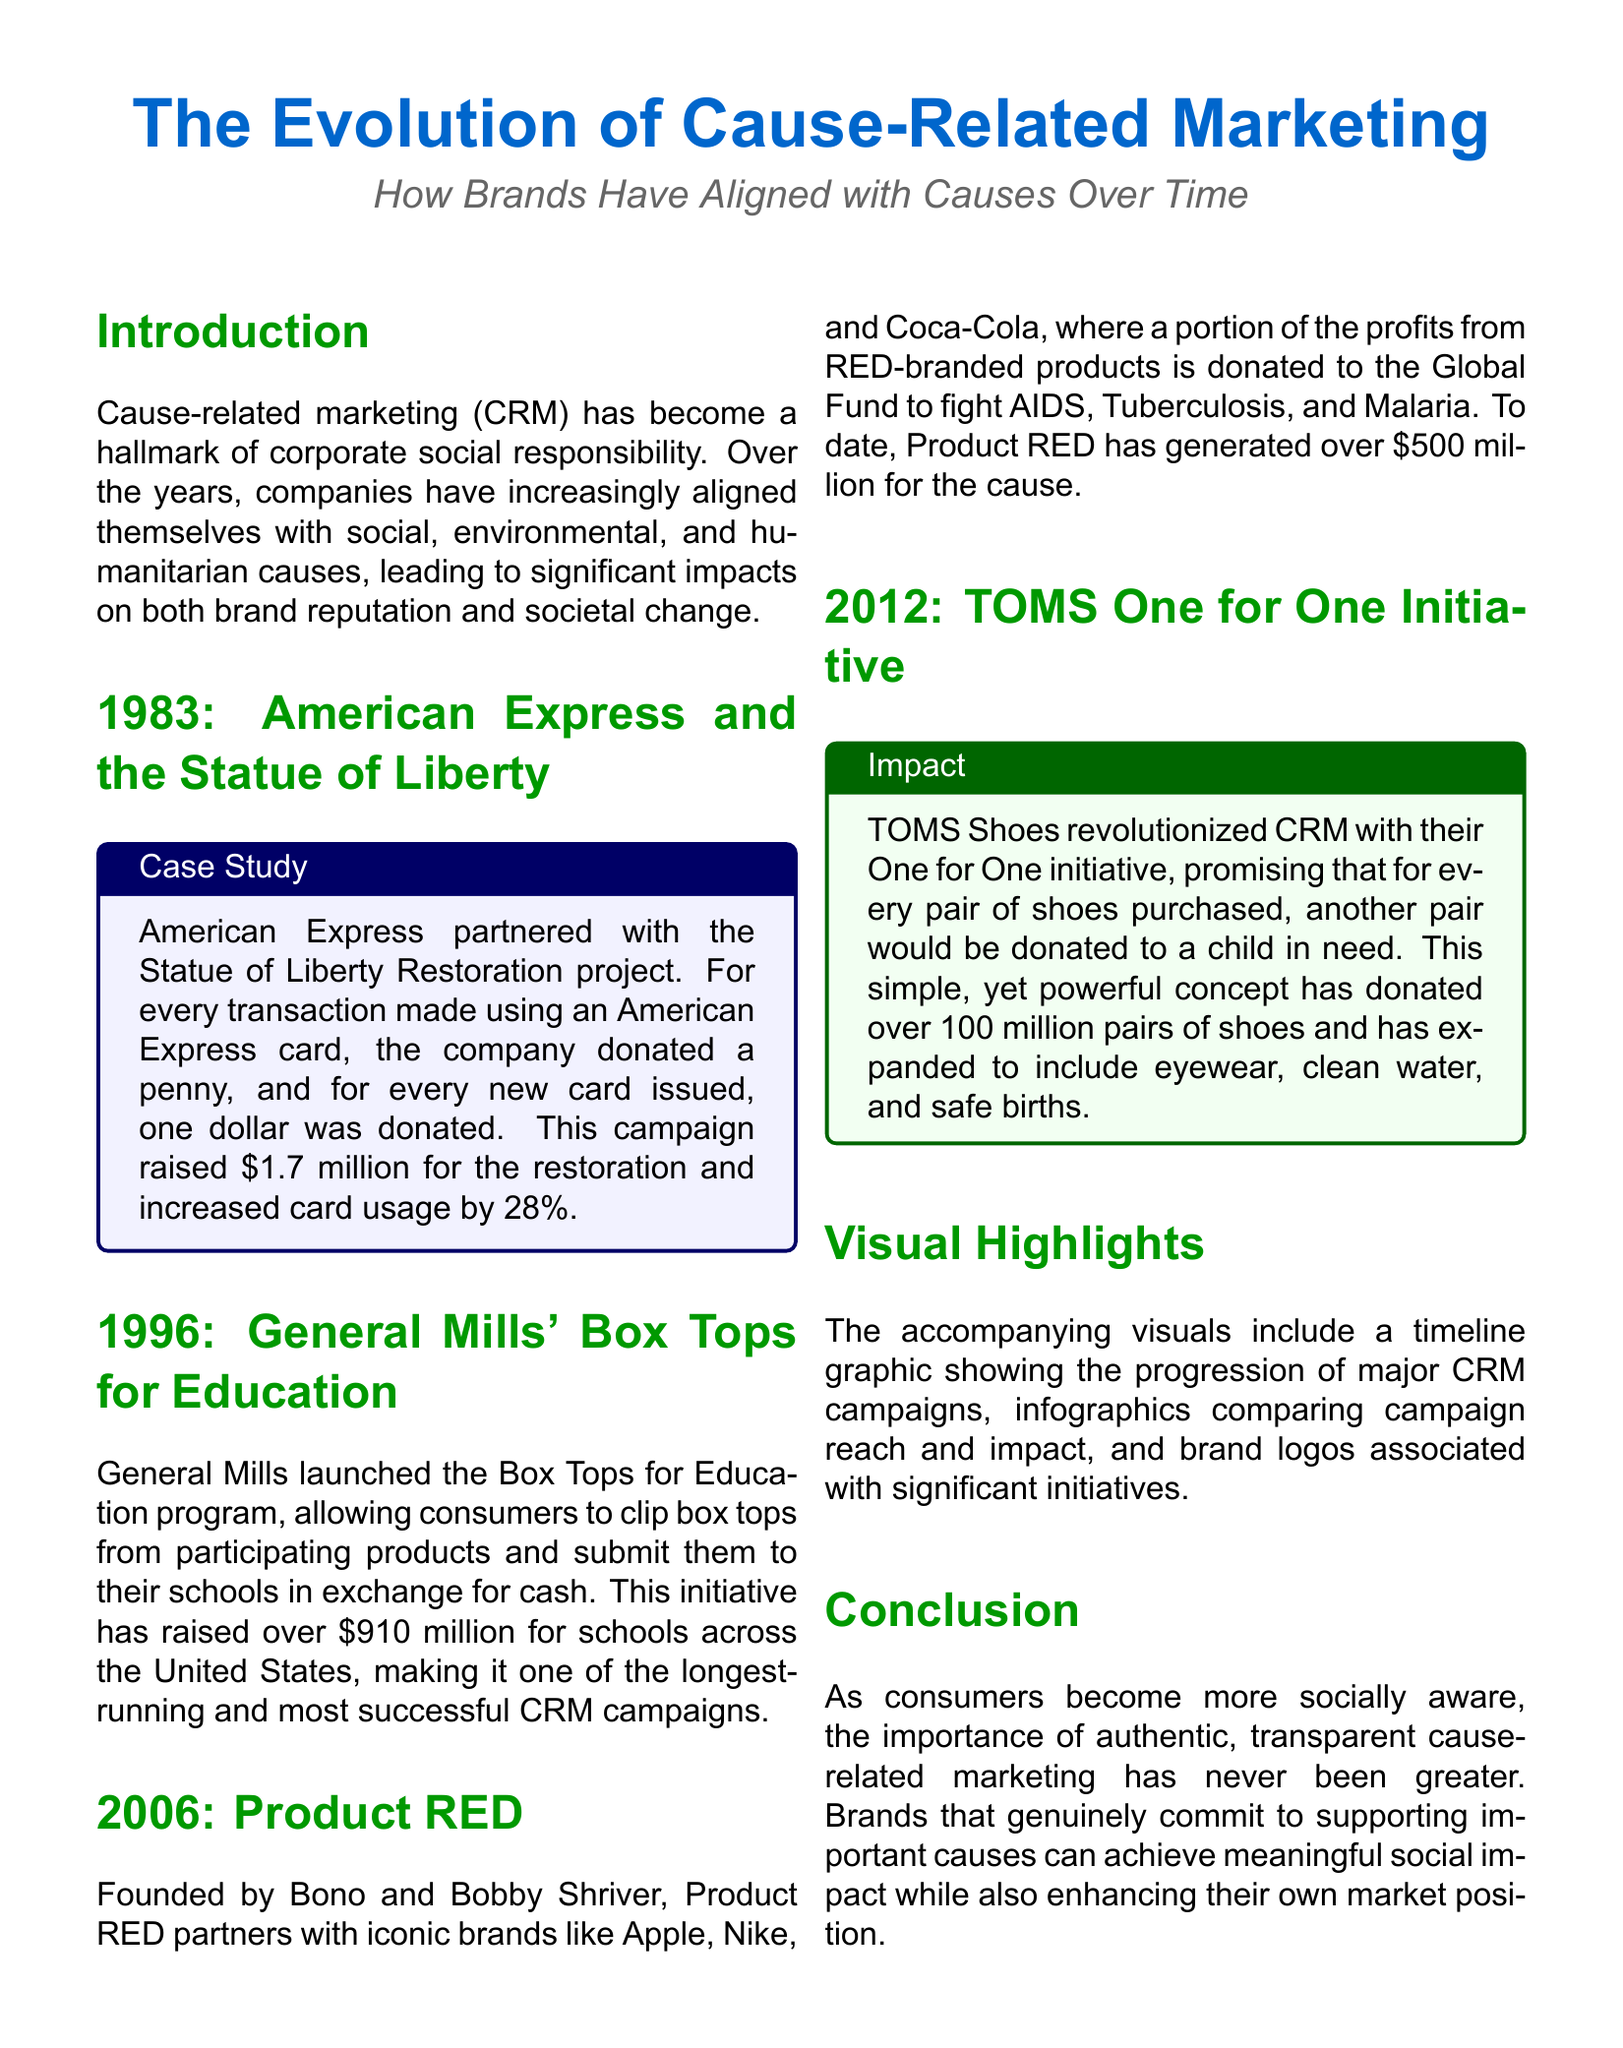What year did American Express partner with the Statue of Liberty? The year American Express partnered with the Statue of Liberty is mentioned in the corresponding section.
Answer: 1983 How much money did American Express raise for the restoration project? The document specifies the total amount raised by American Express for the Statue of Liberty restoration project.
Answer: 1.7 million What is the main initiative of TOMS Shoes? The document describes TOMS Shoes' initiative aimed at helping children in need.
Answer: One for One How many pairs of shoes has TOMS donated? The document states the total number of pairs of shoes donated through the TOMS initiative.
Answer: 100 million What program did General Mills launch? The document refers to the initiative created by General Mills to support education through product purchases.
Answer: Box Tops for Education In what year did Product RED start? The specific year when Product RED was founded is noted in the document.
Answer: 2006 How much money has Product RED generated for its cause? The document provides the total funds raised by Product RED for fighting AIDS, Tuberculosis, and Malaria.
Answer: 500 million What visual highlights are included in the document? The document mentions the type of visuals included alongside the text.
Answer: Timeline graphic Why is cause-related marketing important for brands today? The conclusion section discusses the significance of cause-related marketing for brands in the current social landscape.
Answer: Authentic, transparent 